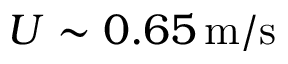<formula> <loc_0><loc_0><loc_500><loc_500>U \sim 0 . 6 5 \, m / s</formula> 